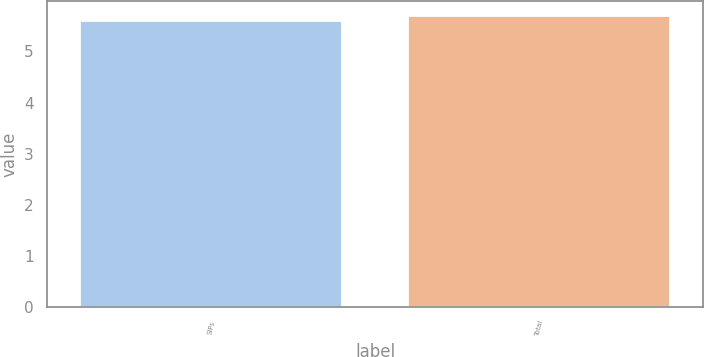Convert chart to OTSL. <chart><loc_0><loc_0><loc_500><loc_500><bar_chart><fcel>SIPs<fcel>Total<nl><fcel>5.6<fcel>5.7<nl></chart> 